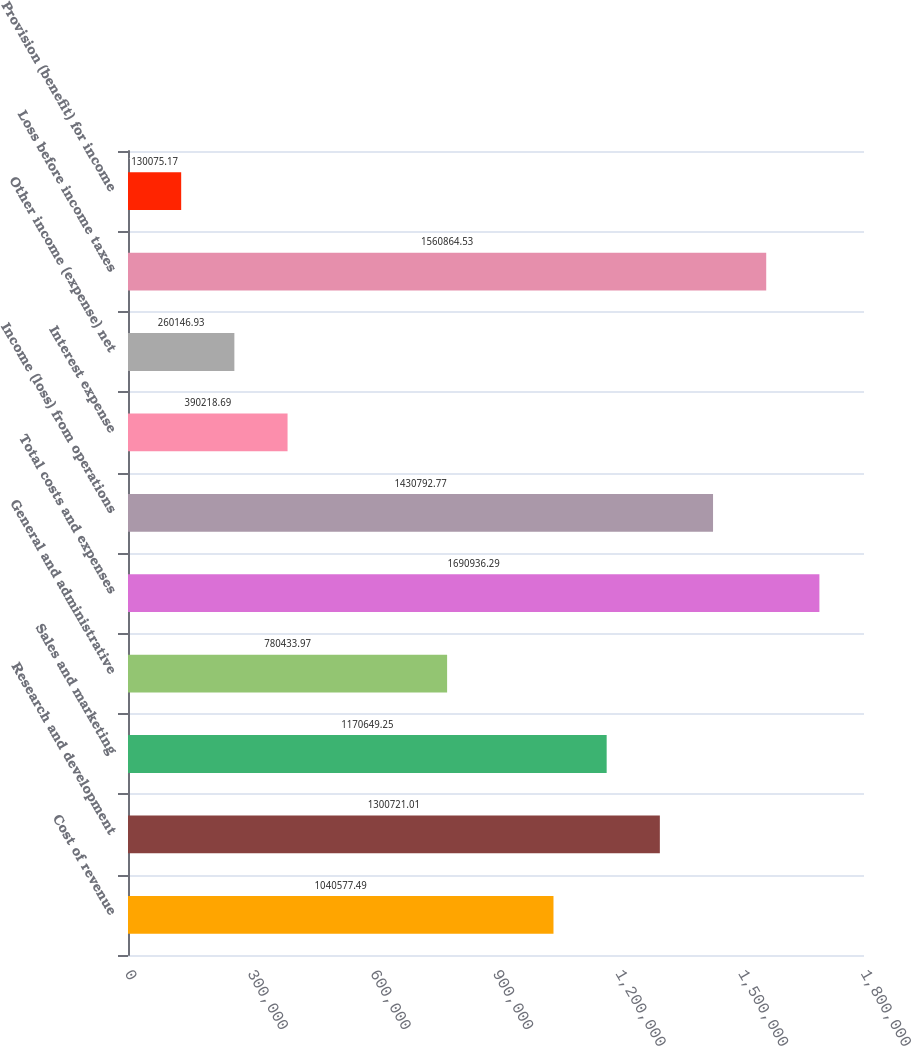Convert chart. <chart><loc_0><loc_0><loc_500><loc_500><bar_chart><fcel>Cost of revenue<fcel>Research and development<fcel>Sales and marketing<fcel>General and administrative<fcel>Total costs and expenses<fcel>Income (loss) from operations<fcel>Interest expense<fcel>Other income (expense) net<fcel>Loss before income taxes<fcel>Provision (benefit) for income<nl><fcel>1.04058e+06<fcel>1.30072e+06<fcel>1.17065e+06<fcel>780434<fcel>1.69094e+06<fcel>1.43079e+06<fcel>390219<fcel>260147<fcel>1.56086e+06<fcel>130075<nl></chart> 